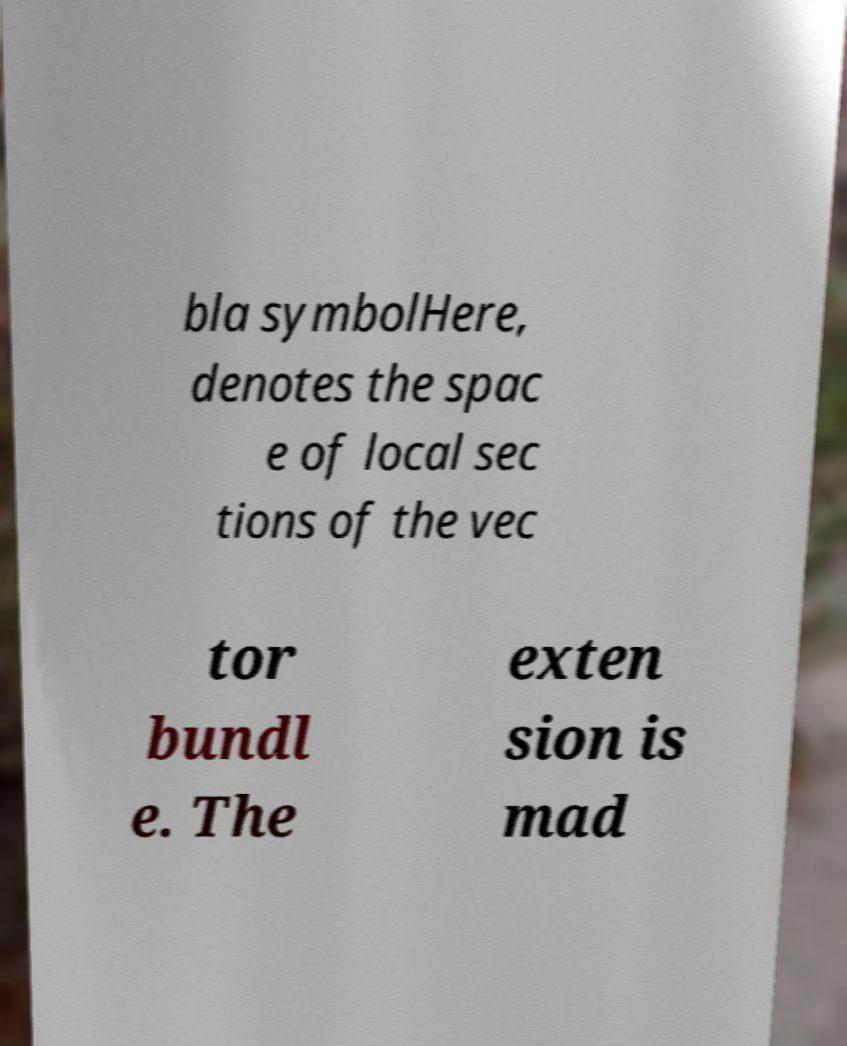Could you extract and type out the text from this image? bla symbolHere, denotes the spac e of local sec tions of the vec tor bundl e. The exten sion is mad 